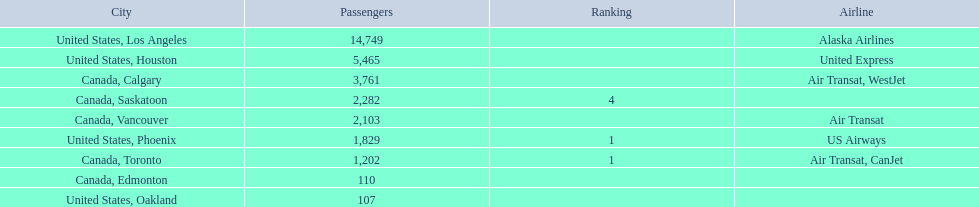What is the average number of passengers in the united states? 5537.5. 